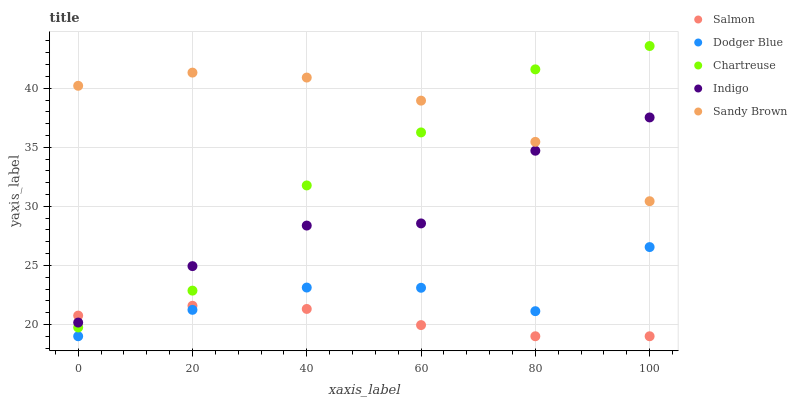Does Salmon have the minimum area under the curve?
Answer yes or no. Yes. Does Sandy Brown have the maximum area under the curve?
Answer yes or no. Yes. Does Chartreuse have the minimum area under the curve?
Answer yes or no. No. Does Chartreuse have the maximum area under the curve?
Answer yes or no. No. Is Salmon the smoothest?
Answer yes or no. Yes. Is Chartreuse the roughest?
Answer yes or no. Yes. Is Chartreuse the smoothest?
Answer yes or no. No. Is Salmon the roughest?
Answer yes or no. No. Does Dodger Blue have the lowest value?
Answer yes or no. Yes. Does Chartreuse have the lowest value?
Answer yes or no. No. Does Chartreuse have the highest value?
Answer yes or no. Yes. Does Salmon have the highest value?
Answer yes or no. No. Is Dodger Blue less than Indigo?
Answer yes or no. Yes. Is Sandy Brown greater than Salmon?
Answer yes or no. Yes. Does Salmon intersect Chartreuse?
Answer yes or no. Yes. Is Salmon less than Chartreuse?
Answer yes or no. No. Is Salmon greater than Chartreuse?
Answer yes or no. No. Does Dodger Blue intersect Indigo?
Answer yes or no. No. 